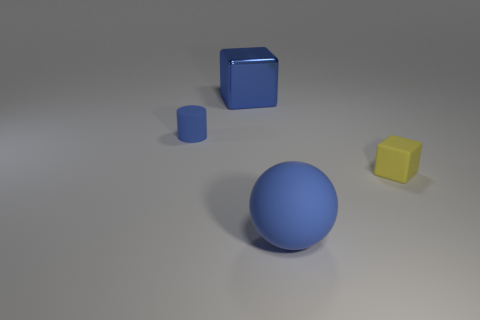Are there any other things that have the same shape as the small blue matte object?
Your response must be concise. No. There is a blue rubber thing that is left of the big matte thing; is its shape the same as the big object in front of the yellow object?
Ensure brevity in your answer.  No. Are there any tiny purple metal objects?
Provide a short and direct response. No. What is the color of the rubber object that is the same shape as the blue metal thing?
Make the answer very short. Yellow. What is the color of the object that is the same size as the yellow rubber cube?
Offer a terse response. Blue. Is the large blue cube made of the same material as the small cylinder?
Make the answer very short. No. How many big matte spheres have the same color as the big shiny object?
Offer a terse response. 1. Is the sphere the same color as the cylinder?
Make the answer very short. Yes. What is the small thing that is on the right side of the big sphere made of?
Offer a very short reply. Rubber. How many big things are rubber things or metallic spheres?
Your response must be concise. 1. 